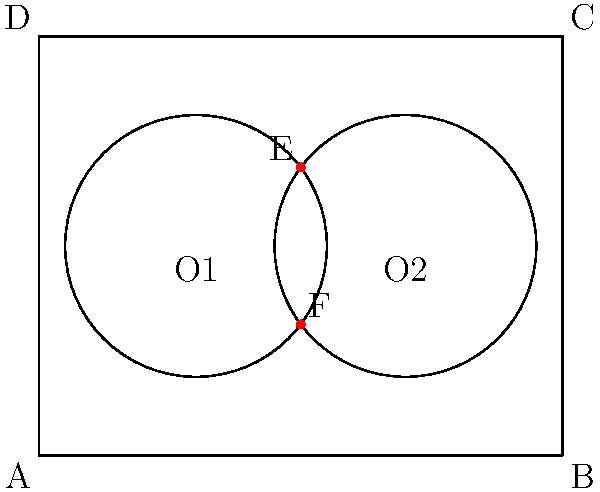In the rectangular office space ABCD, two circular meeting areas with centers O1 and O2 are planned. Both circles have a radius of 2.5 units. If the office space measures 10 units in width and 8 units in length, and the centers of the circles are positioned at (3,4) and (7,4) respectively, what is the area of the region where the two circular meeting areas overlap? To find the area of overlap between the two circular meeting areas, we need to follow these steps:

1) First, we need to find the distance between the centers of the two circles:
   $$d = \sqrt{(7-3)^2 + (4-4)^2} = 4$$ units

2) We know that both circles have the same radius, $r = 2.5$ units.

3) The area of overlap of two circles can be calculated using the formula:
   $$A = 2r^2 \arccos(\frac{d}{2r}) - d\sqrt{r^2 - (\frac{d}{2})^2}$$

4) Let's substitute our values:
   $$A = 2(2.5)^2 \arccos(\frac{4}{2(2.5)}) - 4\sqrt{2.5^2 - (\frac{4}{2})^2}$$

5) Simplify:
   $$A = 12.5 \arccos(0.8) - 4\sqrt{6.25 - 4}$$
   $$A = 12.5 \arccos(0.8) - 4\sqrt{2.25}$$

6) Calculate:
   $$A \approx 12.5(0.6435) - 4(1.5)$$
   $$A \approx 8.04375 - 6$$
   $$A \approx 2.04$$ square units

Therefore, the area of overlap between the two circular meeting areas is approximately 2.04 square units.
Answer: 2.04 square units 